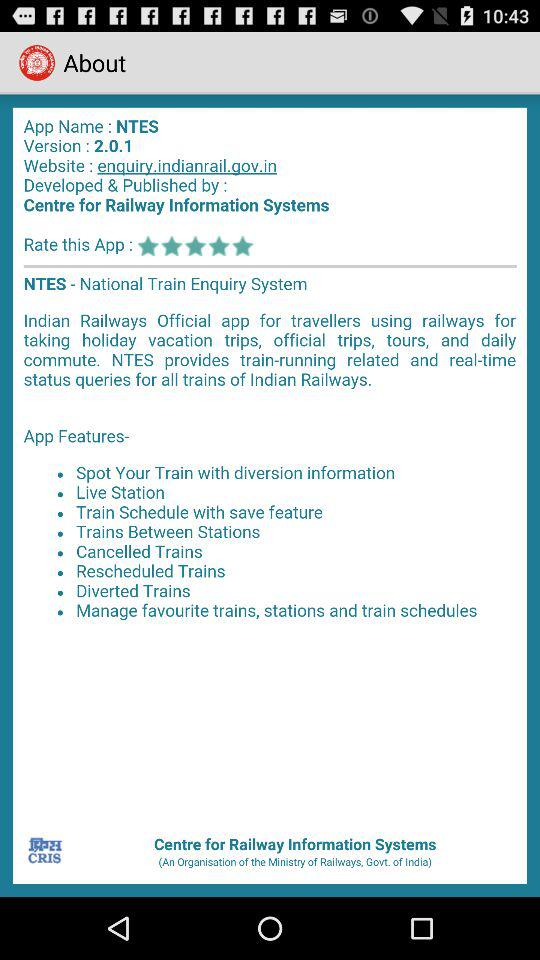Who is the developer and publisher? The developer and publisher is "Centre for Railway Information Systems". 